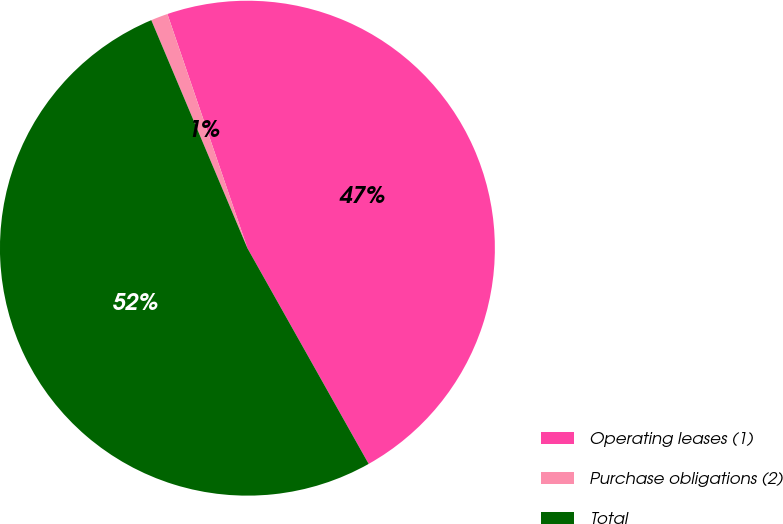Convert chart to OTSL. <chart><loc_0><loc_0><loc_500><loc_500><pie_chart><fcel>Operating leases (1)<fcel>Purchase obligations (2)<fcel>Total<nl><fcel>47.09%<fcel>1.11%<fcel>51.8%<nl></chart> 